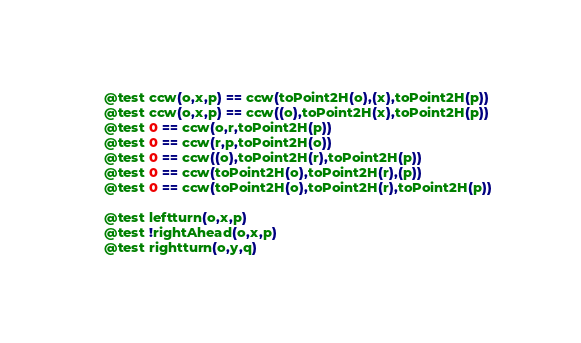<code> <loc_0><loc_0><loc_500><loc_500><_Julia_>	@test ccw(o,x,p) == ccw(toPoint2H(o),(x),toPoint2H(p))
	@test ccw(o,x,p) == ccw((o),toPoint2H(x),toPoint2H(p))
	@test 0 == ccw(o,r,toPoint2H(p))
	@test 0 == ccw(r,p,toPoint2H(o))
	@test 0 == ccw((o),toPoint2H(r),toPoint2H(p))
	@test 0 == ccw(toPoint2H(o),toPoint2H(r),(p))
	@test 0 == ccw(toPoint2H(o),toPoint2H(r),toPoint2H(p))

	@test leftturn(o,x,p)
	@test !rightAhead(o,x,p)
	@test rightturn(o,y,q)</code> 